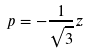<formula> <loc_0><loc_0><loc_500><loc_500>p = - \frac { 1 } { \sqrt { 3 } } z</formula> 